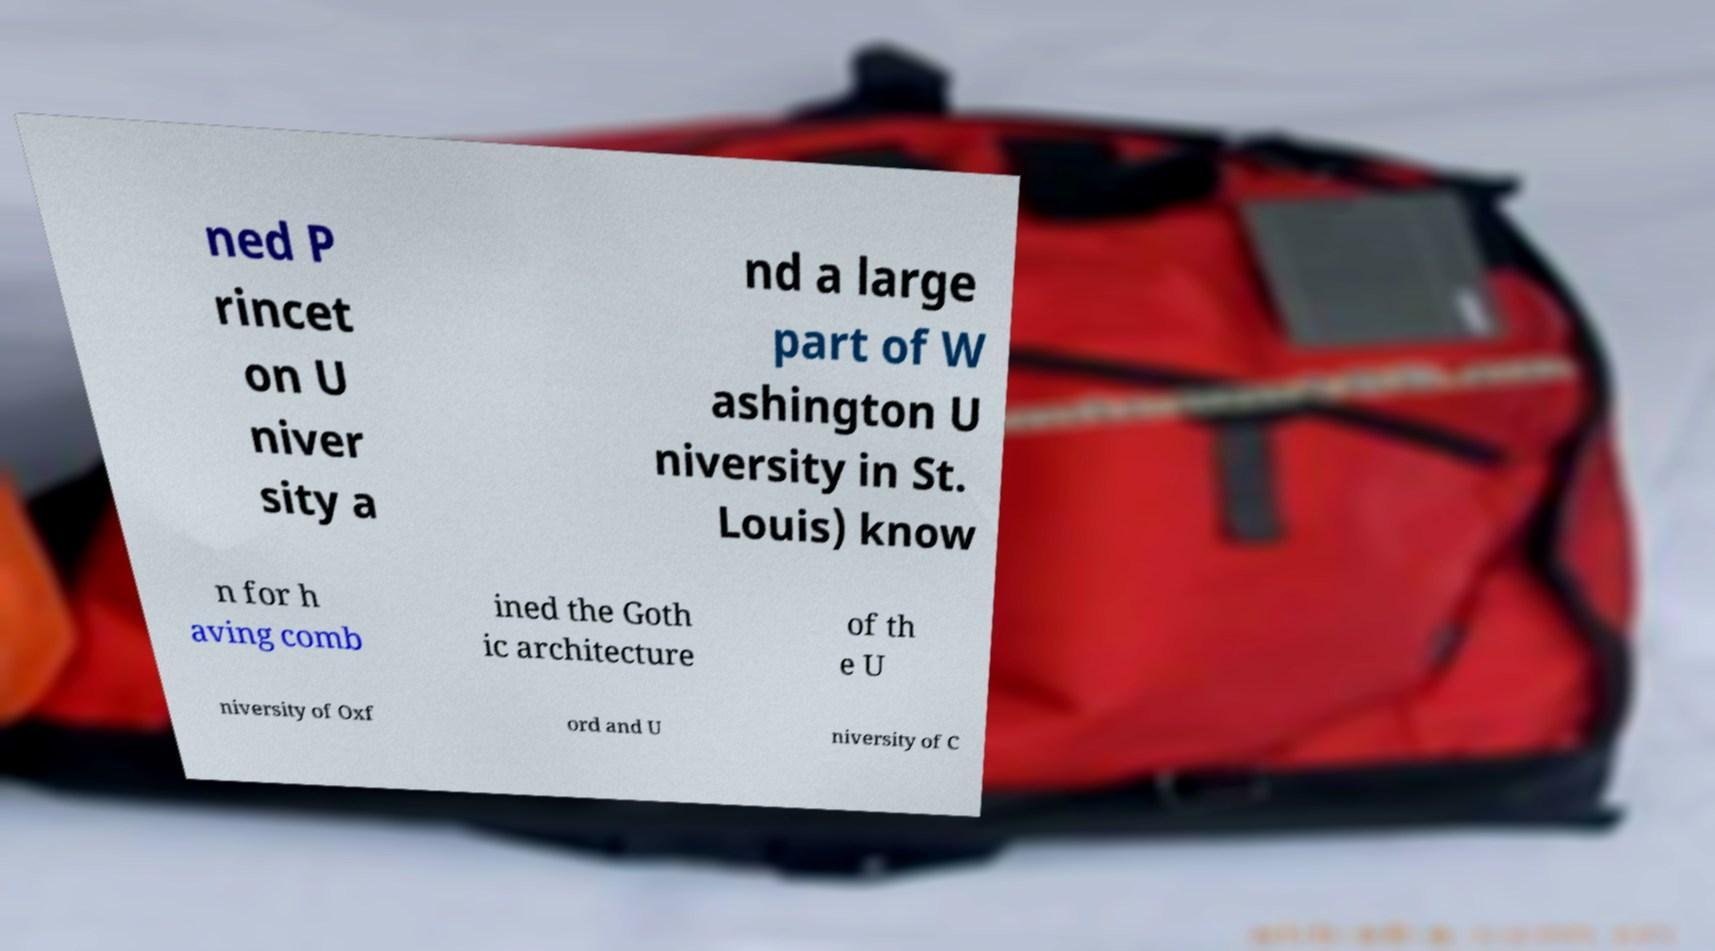There's text embedded in this image that I need extracted. Can you transcribe it verbatim? ned P rincet on U niver sity a nd a large part of W ashington U niversity in St. Louis) know n for h aving comb ined the Goth ic architecture of th e U niversity of Oxf ord and U niversity of C 